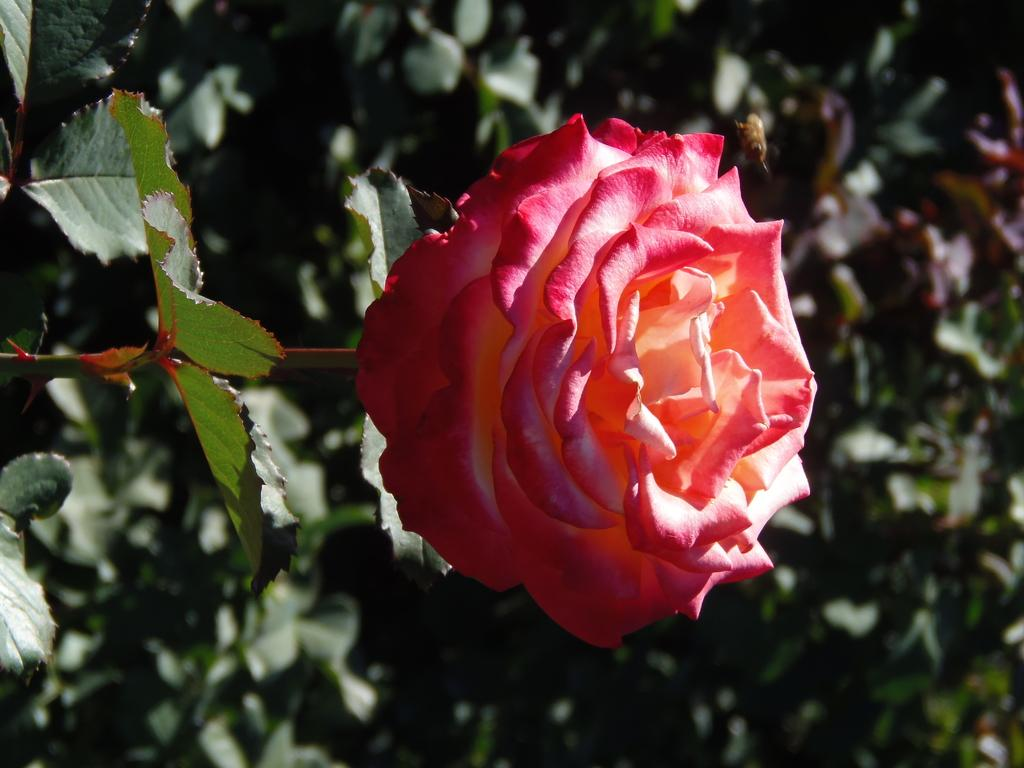What is the main subject in the front of the image? There is a flower in the front of the image. What else can be seen in the image besides the flower? There are leaves in the image. What is visible in the background of the image? There are plants in the background of the image. What type of food is being prepared in the image? There is no food preparation visible in the image; it features a flower, leaves, and plants. Can you provide an example of a different type of flower that might be found in the background of the image? It is not possible to provide an example of a different type of flower based on the information given, as the image only shows the specific flower in the front and plants in the background. 